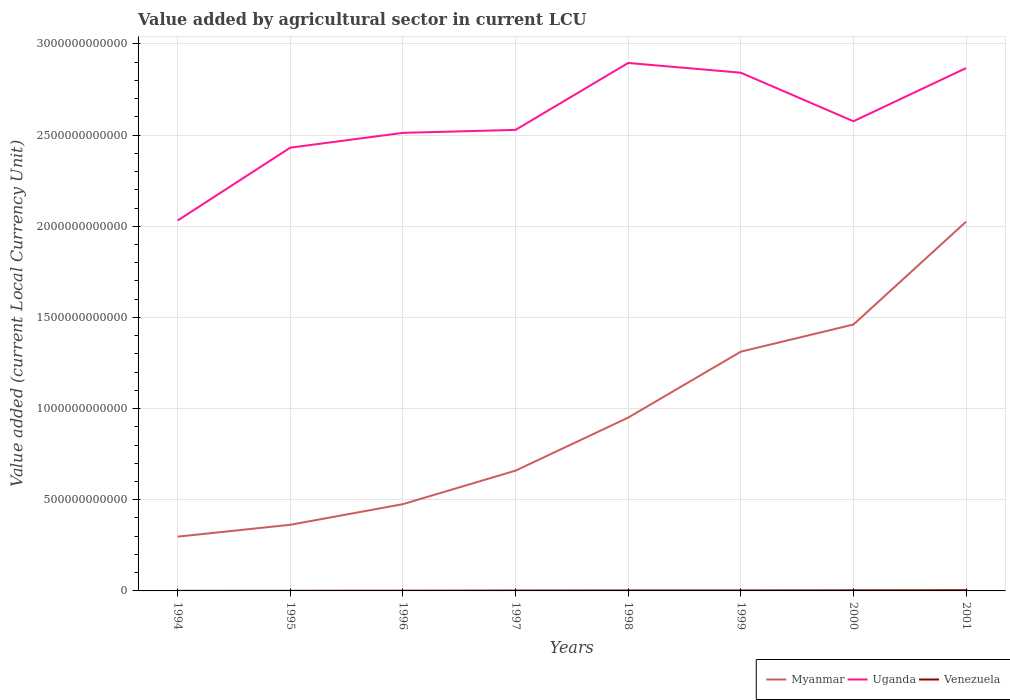Across all years, what is the maximum value added by agricultural sector in Myanmar?
Provide a short and direct response. 2.98e+11. In which year was the value added by agricultural sector in Venezuela maximum?
Provide a short and direct response. 1994. What is the total value added by agricultural sector in Uganda in the graph?
Provide a succinct answer. -6.37e+1. What is the difference between the highest and the second highest value added by agricultural sector in Uganda?
Ensure brevity in your answer.  8.64e+11. What is the difference between the highest and the lowest value added by agricultural sector in Venezuela?
Provide a succinct answer. 4. Is the value added by agricultural sector in Myanmar strictly greater than the value added by agricultural sector in Venezuela over the years?
Offer a very short reply. No. How many years are there in the graph?
Provide a short and direct response. 8. What is the difference between two consecutive major ticks on the Y-axis?
Give a very brief answer. 5.00e+11. Are the values on the major ticks of Y-axis written in scientific E-notation?
Make the answer very short. No. Where does the legend appear in the graph?
Keep it short and to the point. Bottom right. How many legend labels are there?
Give a very brief answer. 3. What is the title of the graph?
Give a very brief answer. Value added by agricultural sector in current LCU. Does "World" appear as one of the legend labels in the graph?
Ensure brevity in your answer.  No. What is the label or title of the X-axis?
Provide a short and direct response. Years. What is the label or title of the Y-axis?
Ensure brevity in your answer.  Value added (current Local Currency Unit). What is the Value added (current Local Currency Unit) in Myanmar in 1994?
Offer a very short reply. 2.98e+11. What is the Value added (current Local Currency Unit) of Uganda in 1994?
Make the answer very short. 2.03e+12. What is the Value added (current Local Currency Unit) of Venezuela in 1994?
Make the answer very short. 4.23e+08. What is the Value added (current Local Currency Unit) of Myanmar in 1995?
Your answer should be very brief. 3.63e+11. What is the Value added (current Local Currency Unit) in Uganda in 1995?
Your answer should be very brief. 2.43e+12. What is the Value added (current Local Currency Unit) of Venezuela in 1995?
Give a very brief answer. 6.90e+08. What is the Value added (current Local Currency Unit) in Myanmar in 1996?
Give a very brief answer. 4.76e+11. What is the Value added (current Local Currency Unit) in Uganda in 1996?
Give a very brief answer. 2.51e+12. What is the Value added (current Local Currency Unit) in Venezuela in 1996?
Offer a terse response. 1.20e+09. What is the Value added (current Local Currency Unit) of Myanmar in 1997?
Provide a succinct answer. 6.60e+11. What is the Value added (current Local Currency Unit) in Uganda in 1997?
Your answer should be very brief. 2.53e+12. What is the Value added (current Local Currency Unit) of Venezuela in 1997?
Offer a very short reply. 1.89e+09. What is the Value added (current Local Currency Unit) in Myanmar in 1998?
Your answer should be very brief. 9.51e+11. What is the Value added (current Local Currency Unit) of Uganda in 1998?
Your response must be concise. 2.90e+12. What is the Value added (current Local Currency Unit) in Venezuela in 1998?
Your answer should be compact. 2.48e+09. What is the Value added (current Local Currency Unit) of Myanmar in 1999?
Provide a short and direct response. 1.31e+12. What is the Value added (current Local Currency Unit) in Uganda in 1999?
Offer a terse response. 2.84e+12. What is the Value added (current Local Currency Unit) in Venezuela in 1999?
Offer a very short reply. 2.58e+09. What is the Value added (current Local Currency Unit) in Myanmar in 2000?
Provide a succinct answer. 1.46e+12. What is the Value added (current Local Currency Unit) of Uganda in 2000?
Provide a succinct answer. 2.58e+12. What is the Value added (current Local Currency Unit) in Venezuela in 2000?
Your answer should be compact. 3.13e+09. What is the Value added (current Local Currency Unit) of Myanmar in 2001?
Make the answer very short. 2.03e+12. What is the Value added (current Local Currency Unit) in Uganda in 2001?
Provide a succinct answer. 2.87e+12. What is the Value added (current Local Currency Unit) in Venezuela in 2001?
Provide a succinct answer. 3.76e+09. Across all years, what is the maximum Value added (current Local Currency Unit) of Myanmar?
Your answer should be very brief. 2.03e+12. Across all years, what is the maximum Value added (current Local Currency Unit) of Uganda?
Offer a terse response. 2.90e+12. Across all years, what is the maximum Value added (current Local Currency Unit) in Venezuela?
Offer a terse response. 3.76e+09. Across all years, what is the minimum Value added (current Local Currency Unit) in Myanmar?
Provide a succinct answer. 2.98e+11. Across all years, what is the minimum Value added (current Local Currency Unit) in Uganda?
Provide a short and direct response. 2.03e+12. Across all years, what is the minimum Value added (current Local Currency Unit) of Venezuela?
Give a very brief answer. 4.23e+08. What is the total Value added (current Local Currency Unit) of Myanmar in the graph?
Provide a short and direct response. 7.55e+12. What is the total Value added (current Local Currency Unit) in Uganda in the graph?
Give a very brief answer. 2.07e+13. What is the total Value added (current Local Currency Unit) of Venezuela in the graph?
Offer a very short reply. 1.62e+1. What is the difference between the Value added (current Local Currency Unit) in Myanmar in 1994 and that in 1995?
Your answer should be compact. -6.51e+1. What is the difference between the Value added (current Local Currency Unit) of Uganda in 1994 and that in 1995?
Offer a terse response. -4.00e+11. What is the difference between the Value added (current Local Currency Unit) in Venezuela in 1994 and that in 1995?
Your answer should be very brief. -2.66e+08. What is the difference between the Value added (current Local Currency Unit) of Myanmar in 1994 and that in 1996?
Your answer should be very brief. -1.78e+11. What is the difference between the Value added (current Local Currency Unit) of Uganda in 1994 and that in 1996?
Ensure brevity in your answer.  -4.81e+11. What is the difference between the Value added (current Local Currency Unit) of Venezuela in 1994 and that in 1996?
Provide a succinct answer. -7.81e+08. What is the difference between the Value added (current Local Currency Unit) of Myanmar in 1994 and that in 1997?
Your answer should be very brief. -3.62e+11. What is the difference between the Value added (current Local Currency Unit) of Uganda in 1994 and that in 1997?
Ensure brevity in your answer.  -4.97e+11. What is the difference between the Value added (current Local Currency Unit) in Venezuela in 1994 and that in 1997?
Ensure brevity in your answer.  -1.46e+09. What is the difference between the Value added (current Local Currency Unit) of Myanmar in 1994 and that in 1998?
Give a very brief answer. -6.53e+11. What is the difference between the Value added (current Local Currency Unit) in Uganda in 1994 and that in 1998?
Offer a very short reply. -8.64e+11. What is the difference between the Value added (current Local Currency Unit) in Venezuela in 1994 and that in 1998?
Make the answer very short. -2.05e+09. What is the difference between the Value added (current Local Currency Unit) of Myanmar in 1994 and that in 1999?
Your answer should be very brief. -1.01e+12. What is the difference between the Value added (current Local Currency Unit) in Uganda in 1994 and that in 1999?
Keep it short and to the point. -8.11e+11. What is the difference between the Value added (current Local Currency Unit) of Venezuela in 1994 and that in 1999?
Ensure brevity in your answer.  -2.16e+09. What is the difference between the Value added (current Local Currency Unit) in Myanmar in 1994 and that in 2000?
Your answer should be compact. -1.16e+12. What is the difference between the Value added (current Local Currency Unit) in Uganda in 1994 and that in 2000?
Ensure brevity in your answer.  -5.44e+11. What is the difference between the Value added (current Local Currency Unit) of Venezuela in 1994 and that in 2000?
Keep it short and to the point. -2.71e+09. What is the difference between the Value added (current Local Currency Unit) in Myanmar in 1994 and that in 2001?
Provide a succinct answer. -1.73e+12. What is the difference between the Value added (current Local Currency Unit) of Uganda in 1994 and that in 2001?
Your answer should be compact. -8.36e+11. What is the difference between the Value added (current Local Currency Unit) of Venezuela in 1994 and that in 2001?
Provide a succinct answer. -3.34e+09. What is the difference between the Value added (current Local Currency Unit) of Myanmar in 1995 and that in 1996?
Provide a short and direct response. -1.13e+11. What is the difference between the Value added (current Local Currency Unit) in Uganda in 1995 and that in 1996?
Your answer should be very brief. -8.11e+1. What is the difference between the Value added (current Local Currency Unit) of Venezuela in 1995 and that in 1996?
Ensure brevity in your answer.  -5.14e+08. What is the difference between the Value added (current Local Currency Unit) in Myanmar in 1995 and that in 1997?
Keep it short and to the point. -2.97e+11. What is the difference between the Value added (current Local Currency Unit) of Uganda in 1995 and that in 1997?
Offer a very short reply. -9.75e+1. What is the difference between the Value added (current Local Currency Unit) in Venezuela in 1995 and that in 1997?
Keep it short and to the point. -1.20e+09. What is the difference between the Value added (current Local Currency Unit) of Myanmar in 1995 and that in 1998?
Keep it short and to the point. -5.88e+11. What is the difference between the Value added (current Local Currency Unit) in Uganda in 1995 and that in 1998?
Provide a succinct answer. -4.64e+11. What is the difference between the Value added (current Local Currency Unit) in Venezuela in 1995 and that in 1998?
Offer a very short reply. -1.79e+09. What is the difference between the Value added (current Local Currency Unit) in Myanmar in 1995 and that in 1999?
Make the answer very short. -9.50e+11. What is the difference between the Value added (current Local Currency Unit) in Uganda in 1995 and that in 1999?
Offer a very short reply. -4.11e+11. What is the difference between the Value added (current Local Currency Unit) in Venezuela in 1995 and that in 1999?
Provide a short and direct response. -1.89e+09. What is the difference between the Value added (current Local Currency Unit) in Myanmar in 1995 and that in 2000?
Ensure brevity in your answer.  -1.10e+12. What is the difference between the Value added (current Local Currency Unit) of Uganda in 1995 and that in 2000?
Make the answer very short. -1.45e+11. What is the difference between the Value added (current Local Currency Unit) in Venezuela in 1995 and that in 2000?
Give a very brief answer. -2.44e+09. What is the difference between the Value added (current Local Currency Unit) in Myanmar in 1995 and that in 2001?
Keep it short and to the point. -1.66e+12. What is the difference between the Value added (current Local Currency Unit) of Uganda in 1995 and that in 2001?
Your response must be concise. -4.36e+11. What is the difference between the Value added (current Local Currency Unit) of Venezuela in 1995 and that in 2001?
Keep it short and to the point. -3.07e+09. What is the difference between the Value added (current Local Currency Unit) in Myanmar in 1996 and that in 1997?
Provide a short and direct response. -1.84e+11. What is the difference between the Value added (current Local Currency Unit) of Uganda in 1996 and that in 1997?
Offer a very short reply. -1.63e+1. What is the difference between the Value added (current Local Currency Unit) of Venezuela in 1996 and that in 1997?
Give a very brief answer. -6.82e+08. What is the difference between the Value added (current Local Currency Unit) of Myanmar in 1996 and that in 1998?
Ensure brevity in your answer.  -4.75e+11. What is the difference between the Value added (current Local Currency Unit) of Uganda in 1996 and that in 1998?
Make the answer very short. -3.83e+11. What is the difference between the Value added (current Local Currency Unit) of Venezuela in 1996 and that in 1998?
Provide a short and direct response. -1.27e+09. What is the difference between the Value added (current Local Currency Unit) in Myanmar in 1996 and that in 1999?
Give a very brief answer. -8.36e+11. What is the difference between the Value added (current Local Currency Unit) of Uganda in 1996 and that in 1999?
Your answer should be compact. -3.30e+11. What is the difference between the Value added (current Local Currency Unit) of Venezuela in 1996 and that in 1999?
Keep it short and to the point. -1.38e+09. What is the difference between the Value added (current Local Currency Unit) of Myanmar in 1996 and that in 2000?
Provide a short and direct response. -9.85e+11. What is the difference between the Value added (current Local Currency Unit) in Uganda in 1996 and that in 2000?
Offer a very short reply. -6.37e+1. What is the difference between the Value added (current Local Currency Unit) of Venezuela in 1996 and that in 2000?
Provide a short and direct response. -1.93e+09. What is the difference between the Value added (current Local Currency Unit) in Myanmar in 1996 and that in 2001?
Give a very brief answer. -1.55e+12. What is the difference between the Value added (current Local Currency Unit) of Uganda in 1996 and that in 2001?
Offer a terse response. -3.55e+11. What is the difference between the Value added (current Local Currency Unit) in Venezuela in 1996 and that in 2001?
Ensure brevity in your answer.  -2.56e+09. What is the difference between the Value added (current Local Currency Unit) of Myanmar in 1997 and that in 1998?
Provide a succinct answer. -2.91e+11. What is the difference between the Value added (current Local Currency Unit) in Uganda in 1997 and that in 1998?
Provide a succinct answer. -3.67e+11. What is the difference between the Value added (current Local Currency Unit) of Venezuela in 1997 and that in 1998?
Offer a very short reply. -5.90e+08. What is the difference between the Value added (current Local Currency Unit) in Myanmar in 1997 and that in 1999?
Give a very brief answer. -6.53e+11. What is the difference between the Value added (current Local Currency Unit) in Uganda in 1997 and that in 1999?
Provide a succinct answer. -3.14e+11. What is the difference between the Value added (current Local Currency Unit) in Venezuela in 1997 and that in 1999?
Offer a very short reply. -6.97e+08. What is the difference between the Value added (current Local Currency Unit) in Myanmar in 1997 and that in 2000?
Your answer should be very brief. -8.01e+11. What is the difference between the Value added (current Local Currency Unit) of Uganda in 1997 and that in 2000?
Offer a very short reply. -4.74e+1. What is the difference between the Value added (current Local Currency Unit) of Venezuela in 1997 and that in 2000?
Give a very brief answer. -1.25e+09. What is the difference between the Value added (current Local Currency Unit) in Myanmar in 1997 and that in 2001?
Your answer should be very brief. -1.37e+12. What is the difference between the Value added (current Local Currency Unit) of Uganda in 1997 and that in 2001?
Offer a very short reply. -3.39e+11. What is the difference between the Value added (current Local Currency Unit) of Venezuela in 1997 and that in 2001?
Offer a very short reply. -1.88e+09. What is the difference between the Value added (current Local Currency Unit) in Myanmar in 1998 and that in 1999?
Ensure brevity in your answer.  -3.62e+11. What is the difference between the Value added (current Local Currency Unit) in Uganda in 1998 and that in 1999?
Your answer should be compact. 5.34e+1. What is the difference between the Value added (current Local Currency Unit) of Venezuela in 1998 and that in 1999?
Offer a very short reply. -1.06e+08. What is the difference between the Value added (current Local Currency Unit) of Myanmar in 1998 and that in 2000?
Provide a succinct answer. -5.11e+11. What is the difference between the Value added (current Local Currency Unit) of Uganda in 1998 and that in 2000?
Offer a terse response. 3.20e+11. What is the difference between the Value added (current Local Currency Unit) of Venezuela in 1998 and that in 2000?
Ensure brevity in your answer.  -6.57e+08. What is the difference between the Value added (current Local Currency Unit) of Myanmar in 1998 and that in 2001?
Provide a succinct answer. -1.07e+12. What is the difference between the Value added (current Local Currency Unit) of Uganda in 1998 and that in 2001?
Your answer should be compact. 2.81e+1. What is the difference between the Value added (current Local Currency Unit) of Venezuela in 1998 and that in 2001?
Keep it short and to the point. -1.29e+09. What is the difference between the Value added (current Local Currency Unit) of Myanmar in 1999 and that in 2000?
Offer a terse response. -1.49e+11. What is the difference between the Value added (current Local Currency Unit) of Uganda in 1999 and that in 2000?
Your answer should be very brief. 2.66e+11. What is the difference between the Value added (current Local Currency Unit) of Venezuela in 1999 and that in 2000?
Make the answer very short. -5.51e+08. What is the difference between the Value added (current Local Currency Unit) of Myanmar in 1999 and that in 2001?
Keep it short and to the point. -7.13e+11. What is the difference between the Value added (current Local Currency Unit) in Uganda in 1999 and that in 2001?
Your response must be concise. -2.53e+1. What is the difference between the Value added (current Local Currency Unit) of Venezuela in 1999 and that in 2001?
Provide a short and direct response. -1.18e+09. What is the difference between the Value added (current Local Currency Unit) of Myanmar in 2000 and that in 2001?
Provide a short and direct response. -5.64e+11. What is the difference between the Value added (current Local Currency Unit) in Uganda in 2000 and that in 2001?
Ensure brevity in your answer.  -2.92e+11. What is the difference between the Value added (current Local Currency Unit) in Venezuela in 2000 and that in 2001?
Your answer should be compact. -6.31e+08. What is the difference between the Value added (current Local Currency Unit) in Myanmar in 1994 and the Value added (current Local Currency Unit) in Uganda in 1995?
Make the answer very short. -2.13e+12. What is the difference between the Value added (current Local Currency Unit) of Myanmar in 1994 and the Value added (current Local Currency Unit) of Venezuela in 1995?
Give a very brief answer. 2.97e+11. What is the difference between the Value added (current Local Currency Unit) of Uganda in 1994 and the Value added (current Local Currency Unit) of Venezuela in 1995?
Offer a terse response. 2.03e+12. What is the difference between the Value added (current Local Currency Unit) in Myanmar in 1994 and the Value added (current Local Currency Unit) in Uganda in 1996?
Make the answer very short. -2.21e+12. What is the difference between the Value added (current Local Currency Unit) in Myanmar in 1994 and the Value added (current Local Currency Unit) in Venezuela in 1996?
Give a very brief answer. 2.96e+11. What is the difference between the Value added (current Local Currency Unit) in Uganda in 1994 and the Value added (current Local Currency Unit) in Venezuela in 1996?
Make the answer very short. 2.03e+12. What is the difference between the Value added (current Local Currency Unit) in Myanmar in 1994 and the Value added (current Local Currency Unit) in Uganda in 1997?
Provide a succinct answer. -2.23e+12. What is the difference between the Value added (current Local Currency Unit) of Myanmar in 1994 and the Value added (current Local Currency Unit) of Venezuela in 1997?
Your answer should be compact. 2.96e+11. What is the difference between the Value added (current Local Currency Unit) of Uganda in 1994 and the Value added (current Local Currency Unit) of Venezuela in 1997?
Your answer should be very brief. 2.03e+12. What is the difference between the Value added (current Local Currency Unit) in Myanmar in 1994 and the Value added (current Local Currency Unit) in Uganda in 1998?
Give a very brief answer. -2.60e+12. What is the difference between the Value added (current Local Currency Unit) of Myanmar in 1994 and the Value added (current Local Currency Unit) of Venezuela in 1998?
Give a very brief answer. 2.95e+11. What is the difference between the Value added (current Local Currency Unit) of Uganda in 1994 and the Value added (current Local Currency Unit) of Venezuela in 1998?
Ensure brevity in your answer.  2.03e+12. What is the difference between the Value added (current Local Currency Unit) of Myanmar in 1994 and the Value added (current Local Currency Unit) of Uganda in 1999?
Your answer should be very brief. -2.54e+12. What is the difference between the Value added (current Local Currency Unit) in Myanmar in 1994 and the Value added (current Local Currency Unit) in Venezuela in 1999?
Offer a very short reply. 2.95e+11. What is the difference between the Value added (current Local Currency Unit) in Uganda in 1994 and the Value added (current Local Currency Unit) in Venezuela in 1999?
Offer a terse response. 2.03e+12. What is the difference between the Value added (current Local Currency Unit) in Myanmar in 1994 and the Value added (current Local Currency Unit) in Uganda in 2000?
Provide a succinct answer. -2.28e+12. What is the difference between the Value added (current Local Currency Unit) in Myanmar in 1994 and the Value added (current Local Currency Unit) in Venezuela in 2000?
Your answer should be compact. 2.95e+11. What is the difference between the Value added (current Local Currency Unit) of Uganda in 1994 and the Value added (current Local Currency Unit) of Venezuela in 2000?
Your answer should be very brief. 2.03e+12. What is the difference between the Value added (current Local Currency Unit) in Myanmar in 1994 and the Value added (current Local Currency Unit) in Uganda in 2001?
Ensure brevity in your answer.  -2.57e+12. What is the difference between the Value added (current Local Currency Unit) of Myanmar in 1994 and the Value added (current Local Currency Unit) of Venezuela in 2001?
Ensure brevity in your answer.  2.94e+11. What is the difference between the Value added (current Local Currency Unit) of Uganda in 1994 and the Value added (current Local Currency Unit) of Venezuela in 2001?
Make the answer very short. 2.03e+12. What is the difference between the Value added (current Local Currency Unit) in Myanmar in 1995 and the Value added (current Local Currency Unit) in Uganda in 1996?
Offer a very short reply. -2.15e+12. What is the difference between the Value added (current Local Currency Unit) of Myanmar in 1995 and the Value added (current Local Currency Unit) of Venezuela in 1996?
Your answer should be compact. 3.62e+11. What is the difference between the Value added (current Local Currency Unit) of Uganda in 1995 and the Value added (current Local Currency Unit) of Venezuela in 1996?
Provide a succinct answer. 2.43e+12. What is the difference between the Value added (current Local Currency Unit) in Myanmar in 1995 and the Value added (current Local Currency Unit) in Uganda in 1997?
Provide a succinct answer. -2.17e+12. What is the difference between the Value added (current Local Currency Unit) in Myanmar in 1995 and the Value added (current Local Currency Unit) in Venezuela in 1997?
Make the answer very short. 3.61e+11. What is the difference between the Value added (current Local Currency Unit) of Uganda in 1995 and the Value added (current Local Currency Unit) of Venezuela in 1997?
Your response must be concise. 2.43e+12. What is the difference between the Value added (current Local Currency Unit) in Myanmar in 1995 and the Value added (current Local Currency Unit) in Uganda in 1998?
Offer a terse response. -2.53e+12. What is the difference between the Value added (current Local Currency Unit) in Myanmar in 1995 and the Value added (current Local Currency Unit) in Venezuela in 1998?
Keep it short and to the point. 3.60e+11. What is the difference between the Value added (current Local Currency Unit) of Uganda in 1995 and the Value added (current Local Currency Unit) of Venezuela in 1998?
Ensure brevity in your answer.  2.43e+12. What is the difference between the Value added (current Local Currency Unit) in Myanmar in 1995 and the Value added (current Local Currency Unit) in Uganda in 1999?
Provide a short and direct response. -2.48e+12. What is the difference between the Value added (current Local Currency Unit) of Myanmar in 1995 and the Value added (current Local Currency Unit) of Venezuela in 1999?
Make the answer very short. 3.60e+11. What is the difference between the Value added (current Local Currency Unit) of Uganda in 1995 and the Value added (current Local Currency Unit) of Venezuela in 1999?
Make the answer very short. 2.43e+12. What is the difference between the Value added (current Local Currency Unit) in Myanmar in 1995 and the Value added (current Local Currency Unit) in Uganda in 2000?
Give a very brief answer. -2.21e+12. What is the difference between the Value added (current Local Currency Unit) in Myanmar in 1995 and the Value added (current Local Currency Unit) in Venezuela in 2000?
Your answer should be compact. 3.60e+11. What is the difference between the Value added (current Local Currency Unit) in Uganda in 1995 and the Value added (current Local Currency Unit) in Venezuela in 2000?
Your response must be concise. 2.43e+12. What is the difference between the Value added (current Local Currency Unit) of Myanmar in 1995 and the Value added (current Local Currency Unit) of Uganda in 2001?
Give a very brief answer. -2.50e+12. What is the difference between the Value added (current Local Currency Unit) of Myanmar in 1995 and the Value added (current Local Currency Unit) of Venezuela in 2001?
Ensure brevity in your answer.  3.59e+11. What is the difference between the Value added (current Local Currency Unit) of Uganda in 1995 and the Value added (current Local Currency Unit) of Venezuela in 2001?
Keep it short and to the point. 2.43e+12. What is the difference between the Value added (current Local Currency Unit) of Myanmar in 1996 and the Value added (current Local Currency Unit) of Uganda in 1997?
Your answer should be very brief. -2.05e+12. What is the difference between the Value added (current Local Currency Unit) of Myanmar in 1996 and the Value added (current Local Currency Unit) of Venezuela in 1997?
Offer a very short reply. 4.74e+11. What is the difference between the Value added (current Local Currency Unit) in Uganda in 1996 and the Value added (current Local Currency Unit) in Venezuela in 1997?
Offer a terse response. 2.51e+12. What is the difference between the Value added (current Local Currency Unit) in Myanmar in 1996 and the Value added (current Local Currency Unit) in Uganda in 1998?
Provide a short and direct response. -2.42e+12. What is the difference between the Value added (current Local Currency Unit) of Myanmar in 1996 and the Value added (current Local Currency Unit) of Venezuela in 1998?
Keep it short and to the point. 4.73e+11. What is the difference between the Value added (current Local Currency Unit) in Uganda in 1996 and the Value added (current Local Currency Unit) in Venezuela in 1998?
Make the answer very short. 2.51e+12. What is the difference between the Value added (current Local Currency Unit) in Myanmar in 1996 and the Value added (current Local Currency Unit) in Uganda in 1999?
Your answer should be very brief. -2.37e+12. What is the difference between the Value added (current Local Currency Unit) in Myanmar in 1996 and the Value added (current Local Currency Unit) in Venezuela in 1999?
Your response must be concise. 4.73e+11. What is the difference between the Value added (current Local Currency Unit) of Uganda in 1996 and the Value added (current Local Currency Unit) of Venezuela in 1999?
Keep it short and to the point. 2.51e+12. What is the difference between the Value added (current Local Currency Unit) of Myanmar in 1996 and the Value added (current Local Currency Unit) of Uganda in 2000?
Make the answer very short. -2.10e+12. What is the difference between the Value added (current Local Currency Unit) in Myanmar in 1996 and the Value added (current Local Currency Unit) in Venezuela in 2000?
Offer a terse response. 4.73e+11. What is the difference between the Value added (current Local Currency Unit) in Uganda in 1996 and the Value added (current Local Currency Unit) in Venezuela in 2000?
Your response must be concise. 2.51e+12. What is the difference between the Value added (current Local Currency Unit) of Myanmar in 1996 and the Value added (current Local Currency Unit) of Uganda in 2001?
Give a very brief answer. -2.39e+12. What is the difference between the Value added (current Local Currency Unit) in Myanmar in 1996 and the Value added (current Local Currency Unit) in Venezuela in 2001?
Provide a short and direct response. 4.72e+11. What is the difference between the Value added (current Local Currency Unit) in Uganda in 1996 and the Value added (current Local Currency Unit) in Venezuela in 2001?
Ensure brevity in your answer.  2.51e+12. What is the difference between the Value added (current Local Currency Unit) of Myanmar in 1997 and the Value added (current Local Currency Unit) of Uganda in 1998?
Your response must be concise. -2.24e+12. What is the difference between the Value added (current Local Currency Unit) of Myanmar in 1997 and the Value added (current Local Currency Unit) of Venezuela in 1998?
Ensure brevity in your answer.  6.57e+11. What is the difference between the Value added (current Local Currency Unit) of Uganda in 1997 and the Value added (current Local Currency Unit) of Venezuela in 1998?
Provide a short and direct response. 2.53e+12. What is the difference between the Value added (current Local Currency Unit) in Myanmar in 1997 and the Value added (current Local Currency Unit) in Uganda in 1999?
Your response must be concise. -2.18e+12. What is the difference between the Value added (current Local Currency Unit) in Myanmar in 1997 and the Value added (current Local Currency Unit) in Venezuela in 1999?
Provide a short and direct response. 6.57e+11. What is the difference between the Value added (current Local Currency Unit) in Uganda in 1997 and the Value added (current Local Currency Unit) in Venezuela in 1999?
Keep it short and to the point. 2.53e+12. What is the difference between the Value added (current Local Currency Unit) in Myanmar in 1997 and the Value added (current Local Currency Unit) in Uganda in 2000?
Keep it short and to the point. -1.92e+12. What is the difference between the Value added (current Local Currency Unit) in Myanmar in 1997 and the Value added (current Local Currency Unit) in Venezuela in 2000?
Offer a very short reply. 6.57e+11. What is the difference between the Value added (current Local Currency Unit) in Uganda in 1997 and the Value added (current Local Currency Unit) in Venezuela in 2000?
Offer a terse response. 2.53e+12. What is the difference between the Value added (current Local Currency Unit) in Myanmar in 1997 and the Value added (current Local Currency Unit) in Uganda in 2001?
Your response must be concise. -2.21e+12. What is the difference between the Value added (current Local Currency Unit) of Myanmar in 1997 and the Value added (current Local Currency Unit) of Venezuela in 2001?
Ensure brevity in your answer.  6.56e+11. What is the difference between the Value added (current Local Currency Unit) of Uganda in 1997 and the Value added (current Local Currency Unit) of Venezuela in 2001?
Provide a succinct answer. 2.52e+12. What is the difference between the Value added (current Local Currency Unit) in Myanmar in 1998 and the Value added (current Local Currency Unit) in Uganda in 1999?
Your answer should be compact. -1.89e+12. What is the difference between the Value added (current Local Currency Unit) in Myanmar in 1998 and the Value added (current Local Currency Unit) in Venezuela in 1999?
Keep it short and to the point. 9.48e+11. What is the difference between the Value added (current Local Currency Unit) of Uganda in 1998 and the Value added (current Local Currency Unit) of Venezuela in 1999?
Offer a very short reply. 2.89e+12. What is the difference between the Value added (current Local Currency Unit) of Myanmar in 1998 and the Value added (current Local Currency Unit) of Uganda in 2000?
Keep it short and to the point. -1.63e+12. What is the difference between the Value added (current Local Currency Unit) in Myanmar in 1998 and the Value added (current Local Currency Unit) in Venezuela in 2000?
Provide a short and direct response. 9.47e+11. What is the difference between the Value added (current Local Currency Unit) in Uganda in 1998 and the Value added (current Local Currency Unit) in Venezuela in 2000?
Keep it short and to the point. 2.89e+12. What is the difference between the Value added (current Local Currency Unit) of Myanmar in 1998 and the Value added (current Local Currency Unit) of Uganda in 2001?
Provide a succinct answer. -1.92e+12. What is the difference between the Value added (current Local Currency Unit) of Myanmar in 1998 and the Value added (current Local Currency Unit) of Venezuela in 2001?
Provide a short and direct response. 9.47e+11. What is the difference between the Value added (current Local Currency Unit) of Uganda in 1998 and the Value added (current Local Currency Unit) of Venezuela in 2001?
Your answer should be very brief. 2.89e+12. What is the difference between the Value added (current Local Currency Unit) in Myanmar in 1999 and the Value added (current Local Currency Unit) in Uganda in 2000?
Your answer should be very brief. -1.26e+12. What is the difference between the Value added (current Local Currency Unit) in Myanmar in 1999 and the Value added (current Local Currency Unit) in Venezuela in 2000?
Give a very brief answer. 1.31e+12. What is the difference between the Value added (current Local Currency Unit) in Uganda in 1999 and the Value added (current Local Currency Unit) in Venezuela in 2000?
Provide a succinct answer. 2.84e+12. What is the difference between the Value added (current Local Currency Unit) in Myanmar in 1999 and the Value added (current Local Currency Unit) in Uganda in 2001?
Give a very brief answer. -1.56e+12. What is the difference between the Value added (current Local Currency Unit) of Myanmar in 1999 and the Value added (current Local Currency Unit) of Venezuela in 2001?
Your response must be concise. 1.31e+12. What is the difference between the Value added (current Local Currency Unit) in Uganda in 1999 and the Value added (current Local Currency Unit) in Venezuela in 2001?
Offer a very short reply. 2.84e+12. What is the difference between the Value added (current Local Currency Unit) of Myanmar in 2000 and the Value added (current Local Currency Unit) of Uganda in 2001?
Make the answer very short. -1.41e+12. What is the difference between the Value added (current Local Currency Unit) in Myanmar in 2000 and the Value added (current Local Currency Unit) in Venezuela in 2001?
Provide a short and direct response. 1.46e+12. What is the difference between the Value added (current Local Currency Unit) in Uganda in 2000 and the Value added (current Local Currency Unit) in Venezuela in 2001?
Keep it short and to the point. 2.57e+12. What is the average Value added (current Local Currency Unit) in Myanmar per year?
Keep it short and to the point. 9.43e+11. What is the average Value added (current Local Currency Unit) in Uganda per year?
Ensure brevity in your answer.  2.59e+12. What is the average Value added (current Local Currency Unit) in Venezuela per year?
Provide a short and direct response. 2.02e+09. In the year 1994, what is the difference between the Value added (current Local Currency Unit) in Myanmar and Value added (current Local Currency Unit) in Uganda?
Offer a very short reply. -1.73e+12. In the year 1994, what is the difference between the Value added (current Local Currency Unit) of Myanmar and Value added (current Local Currency Unit) of Venezuela?
Your answer should be compact. 2.97e+11. In the year 1994, what is the difference between the Value added (current Local Currency Unit) of Uganda and Value added (current Local Currency Unit) of Venezuela?
Offer a terse response. 2.03e+12. In the year 1995, what is the difference between the Value added (current Local Currency Unit) of Myanmar and Value added (current Local Currency Unit) of Uganda?
Offer a very short reply. -2.07e+12. In the year 1995, what is the difference between the Value added (current Local Currency Unit) of Myanmar and Value added (current Local Currency Unit) of Venezuela?
Your answer should be very brief. 3.62e+11. In the year 1995, what is the difference between the Value added (current Local Currency Unit) in Uganda and Value added (current Local Currency Unit) in Venezuela?
Ensure brevity in your answer.  2.43e+12. In the year 1996, what is the difference between the Value added (current Local Currency Unit) of Myanmar and Value added (current Local Currency Unit) of Uganda?
Give a very brief answer. -2.04e+12. In the year 1996, what is the difference between the Value added (current Local Currency Unit) of Myanmar and Value added (current Local Currency Unit) of Venezuela?
Make the answer very short. 4.75e+11. In the year 1996, what is the difference between the Value added (current Local Currency Unit) of Uganda and Value added (current Local Currency Unit) of Venezuela?
Ensure brevity in your answer.  2.51e+12. In the year 1997, what is the difference between the Value added (current Local Currency Unit) in Myanmar and Value added (current Local Currency Unit) in Uganda?
Give a very brief answer. -1.87e+12. In the year 1997, what is the difference between the Value added (current Local Currency Unit) in Myanmar and Value added (current Local Currency Unit) in Venezuela?
Provide a succinct answer. 6.58e+11. In the year 1997, what is the difference between the Value added (current Local Currency Unit) in Uganda and Value added (current Local Currency Unit) in Venezuela?
Provide a succinct answer. 2.53e+12. In the year 1998, what is the difference between the Value added (current Local Currency Unit) of Myanmar and Value added (current Local Currency Unit) of Uganda?
Provide a short and direct response. -1.95e+12. In the year 1998, what is the difference between the Value added (current Local Currency Unit) in Myanmar and Value added (current Local Currency Unit) in Venezuela?
Provide a succinct answer. 9.48e+11. In the year 1998, what is the difference between the Value added (current Local Currency Unit) of Uganda and Value added (current Local Currency Unit) of Venezuela?
Provide a short and direct response. 2.89e+12. In the year 1999, what is the difference between the Value added (current Local Currency Unit) in Myanmar and Value added (current Local Currency Unit) in Uganda?
Give a very brief answer. -1.53e+12. In the year 1999, what is the difference between the Value added (current Local Currency Unit) in Myanmar and Value added (current Local Currency Unit) in Venezuela?
Ensure brevity in your answer.  1.31e+12. In the year 1999, what is the difference between the Value added (current Local Currency Unit) in Uganda and Value added (current Local Currency Unit) in Venezuela?
Offer a very short reply. 2.84e+12. In the year 2000, what is the difference between the Value added (current Local Currency Unit) of Myanmar and Value added (current Local Currency Unit) of Uganda?
Your response must be concise. -1.11e+12. In the year 2000, what is the difference between the Value added (current Local Currency Unit) in Myanmar and Value added (current Local Currency Unit) in Venezuela?
Ensure brevity in your answer.  1.46e+12. In the year 2000, what is the difference between the Value added (current Local Currency Unit) in Uganda and Value added (current Local Currency Unit) in Venezuela?
Ensure brevity in your answer.  2.57e+12. In the year 2001, what is the difference between the Value added (current Local Currency Unit) in Myanmar and Value added (current Local Currency Unit) in Uganda?
Give a very brief answer. -8.42e+11. In the year 2001, what is the difference between the Value added (current Local Currency Unit) in Myanmar and Value added (current Local Currency Unit) in Venezuela?
Ensure brevity in your answer.  2.02e+12. In the year 2001, what is the difference between the Value added (current Local Currency Unit) in Uganda and Value added (current Local Currency Unit) in Venezuela?
Provide a succinct answer. 2.86e+12. What is the ratio of the Value added (current Local Currency Unit) in Myanmar in 1994 to that in 1995?
Your response must be concise. 0.82. What is the ratio of the Value added (current Local Currency Unit) of Uganda in 1994 to that in 1995?
Your answer should be compact. 0.84. What is the ratio of the Value added (current Local Currency Unit) in Venezuela in 1994 to that in 1995?
Your answer should be compact. 0.61. What is the ratio of the Value added (current Local Currency Unit) of Myanmar in 1994 to that in 1996?
Your response must be concise. 0.63. What is the ratio of the Value added (current Local Currency Unit) in Uganda in 1994 to that in 1996?
Provide a succinct answer. 0.81. What is the ratio of the Value added (current Local Currency Unit) in Venezuela in 1994 to that in 1996?
Offer a very short reply. 0.35. What is the ratio of the Value added (current Local Currency Unit) in Myanmar in 1994 to that in 1997?
Ensure brevity in your answer.  0.45. What is the ratio of the Value added (current Local Currency Unit) in Uganda in 1994 to that in 1997?
Offer a very short reply. 0.8. What is the ratio of the Value added (current Local Currency Unit) of Venezuela in 1994 to that in 1997?
Your answer should be very brief. 0.22. What is the ratio of the Value added (current Local Currency Unit) of Myanmar in 1994 to that in 1998?
Your answer should be very brief. 0.31. What is the ratio of the Value added (current Local Currency Unit) in Uganda in 1994 to that in 1998?
Ensure brevity in your answer.  0.7. What is the ratio of the Value added (current Local Currency Unit) in Venezuela in 1994 to that in 1998?
Give a very brief answer. 0.17. What is the ratio of the Value added (current Local Currency Unit) of Myanmar in 1994 to that in 1999?
Your answer should be compact. 0.23. What is the ratio of the Value added (current Local Currency Unit) in Uganda in 1994 to that in 1999?
Keep it short and to the point. 0.71. What is the ratio of the Value added (current Local Currency Unit) in Venezuela in 1994 to that in 1999?
Give a very brief answer. 0.16. What is the ratio of the Value added (current Local Currency Unit) in Myanmar in 1994 to that in 2000?
Give a very brief answer. 0.2. What is the ratio of the Value added (current Local Currency Unit) in Uganda in 1994 to that in 2000?
Your answer should be very brief. 0.79. What is the ratio of the Value added (current Local Currency Unit) of Venezuela in 1994 to that in 2000?
Offer a terse response. 0.14. What is the ratio of the Value added (current Local Currency Unit) of Myanmar in 1994 to that in 2001?
Give a very brief answer. 0.15. What is the ratio of the Value added (current Local Currency Unit) in Uganda in 1994 to that in 2001?
Provide a short and direct response. 0.71. What is the ratio of the Value added (current Local Currency Unit) of Venezuela in 1994 to that in 2001?
Offer a terse response. 0.11. What is the ratio of the Value added (current Local Currency Unit) of Myanmar in 1995 to that in 1996?
Give a very brief answer. 0.76. What is the ratio of the Value added (current Local Currency Unit) in Uganda in 1995 to that in 1996?
Provide a succinct answer. 0.97. What is the ratio of the Value added (current Local Currency Unit) in Venezuela in 1995 to that in 1996?
Your answer should be very brief. 0.57. What is the ratio of the Value added (current Local Currency Unit) in Myanmar in 1995 to that in 1997?
Offer a very short reply. 0.55. What is the ratio of the Value added (current Local Currency Unit) in Uganda in 1995 to that in 1997?
Give a very brief answer. 0.96. What is the ratio of the Value added (current Local Currency Unit) of Venezuela in 1995 to that in 1997?
Offer a very short reply. 0.37. What is the ratio of the Value added (current Local Currency Unit) of Myanmar in 1995 to that in 1998?
Offer a very short reply. 0.38. What is the ratio of the Value added (current Local Currency Unit) in Uganda in 1995 to that in 1998?
Keep it short and to the point. 0.84. What is the ratio of the Value added (current Local Currency Unit) of Venezuela in 1995 to that in 1998?
Provide a succinct answer. 0.28. What is the ratio of the Value added (current Local Currency Unit) of Myanmar in 1995 to that in 1999?
Your response must be concise. 0.28. What is the ratio of the Value added (current Local Currency Unit) in Uganda in 1995 to that in 1999?
Ensure brevity in your answer.  0.86. What is the ratio of the Value added (current Local Currency Unit) of Venezuela in 1995 to that in 1999?
Provide a succinct answer. 0.27. What is the ratio of the Value added (current Local Currency Unit) of Myanmar in 1995 to that in 2000?
Provide a succinct answer. 0.25. What is the ratio of the Value added (current Local Currency Unit) in Uganda in 1995 to that in 2000?
Provide a succinct answer. 0.94. What is the ratio of the Value added (current Local Currency Unit) of Venezuela in 1995 to that in 2000?
Make the answer very short. 0.22. What is the ratio of the Value added (current Local Currency Unit) of Myanmar in 1995 to that in 2001?
Your response must be concise. 0.18. What is the ratio of the Value added (current Local Currency Unit) of Uganda in 1995 to that in 2001?
Provide a short and direct response. 0.85. What is the ratio of the Value added (current Local Currency Unit) in Venezuela in 1995 to that in 2001?
Give a very brief answer. 0.18. What is the ratio of the Value added (current Local Currency Unit) in Myanmar in 1996 to that in 1997?
Offer a terse response. 0.72. What is the ratio of the Value added (current Local Currency Unit) in Uganda in 1996 to that in 1997?
Your response must be concise. 0.99. What is the ratio of the Value added (current Local Currency Unit) in Venezuela in 1996 to that in 1997?
Your answer should be compact. 0.64. What is the ratio of the Value added (current Local Currency Unit) in Myanmar in 1996 to that in 1998?
Offer a very short reply. 0.5. What is the ratio of the Value added (current Local Currency Unit) in Uganda in 1996 to that in 1998?
Your answer should be compact. 0.87. What is the ratio of the Value added (current Local Currency Unit) of Venezuela in 1996 to that in 1998?
Offer a very short reply. 0.49. What is the ratio of the Value added (current Local Currency Unit) in Myanmar in 1996 to that in 1999?
Your response must be concise. 0.36. What is the ratio of the Value added (current Local Currency Unit) of Uganda in 1996 to that in 1999?
Provide a succinct answer. 0.88. What is the ratio of the Value added (current Local Currency Unit) of Venezuela in 1996 to that in 1999?
Provide a succinct answer. 0.47. What is the ratio of the Value added (current Local Currency Unit) of Myanmar in 1996 to that in 2000?
Provide a short and direct response. 0.33. What is the ratio of the Value added (current Local Currency Unit) of Uganda in 1996 to that in 2000?
Offer a terse response. 0.98. What is the ratio of the Value added (current Local Currency Unit) of Venezuela in 1996 to that in 2000?
Provide a succinct answer. 0.38. What is the ratio of the Value added (current Local Currency Unit) in Myanmar in 1996 to that in 2001?
Offer a terse response. 0.23. What is the ratio of the Value added (current Local Currency Unit) of Uganda in 1996 to that in 2001?
Keep it short and to the point. 0.88. What is the ratio of the Value added (current Local Currency Unit) of Venezuela in 1996 to that in 2001?
Offer a terse response. 0.32. What is the ratio of the Value added (current Local Currency Unit) of Myanmar in 1997 to that in 1998?
Your response must be concise. 0.69. What is the ratio of the Value added (current Local Currency Unit) in Uganda in 1997 to that in 1998?
Keep it short and to the point. 0.87. What is the ratio of the Value added (current Local Currency Unit) in Venezuela in 1997 to that in 1998?
Your answer should be compact. 0.76. What is the ratio of the Value added (current Local Currency Unit) of Myanmar in 1997 to that in 1999?
Make the answer very short. 0.5. What is the ratio of the Value added (current Local Currency Unit) of Uganda in 1997 to that in 1999?
Keep it short and to the point. 0.89. What is the ratio of the Value added (current Local Currency Unit) in Venezuela in 1997 to that in 1999?
Keep it short and to the point. 0.73. What is the ratio of the Value added (current Local Currency Unit) of Myanmar in 1997 to that in 2000?
Offer a terse response. 0.45. What is the ratio of the Value added (current Local Currency Unit) in Uganda in 1997 to that in 2000?
Make the answer very short. 0.98. What is the ratio of the Value added (current Local Currency Unit) in Venezuela in 1997 to that in 2000?
Offer a very short reply. 0.6. What is the ratio of the Value added (current Local Currency Unit) of Myanmar in 1997 to that in 2001?
Your answer should be very brief. 0.33. What is the ratio of the Value added (current Local Currency Unit) of Uganda in 1997 to that in 2001?
Your response must be concise. 0.88. What is the ratio of the Value added (current Local Currency Unit) in Venezuela in 1997 to that in 2001?
Give a very brief answer. 0.5. What is the ratio of the Value added (current Local Currency Unit) in Myanmar in 1998 to that in 1999?
Your response must be concise. 0.72. What is the ratio of the Value added (current Local Currency Unit) of Uganda in 1998 to that in 1999?
Make the answer very short. 1.02. What is the ratio of the Value added (current Local Currency Unit) of Venezuela in 1998 to that in 1999?
Offer a terse response. 0.96. What is the ratio of the Value added (current Local Currency Unit) in Myanmar in 1998 to that in 2000?
Ensure brevity in your answer.  0.65. What is the ratio of the Value added (current Local Currency Unit) in Uganda in 1998 to that in 2000?
Offer a terse response. 1.12. What is the ratio of the Value added (current Local Currency Unit) of Venezuela in 1998 to that in 2000?
Your response must be concise. 0.79. What is the ratio of the Value added (current Local Currency Unit) in Myanmar in 1998 to that in 2001?
Provide a short and direct response. 0.47. What is the ratio of the Value added (current Local Currency Unit) of Uganda in 1998 to that in 2001?
Provide a succinct answer. 1.01. What is the ratio of the Value added (current Local Currency Unit) in Venezuela in 1998 to that in 2001?
Your response must be concise. 0.66. What is the ratio of the Value added (current Local Currency Unit) in Myanmar in 1999 to that in 2000?
Provide a short and direct response. 0.9. What is the ratio of the Value added (current Local Currency Unit) of Uganda in 1999 to that in 2000?
Provide a short and direct response. 1.1. What is the ratio of the Value added (current Local Currency Unit) in Venezuela in 1999 to that in 2000?
Provide a succinct answer. 0.82. What is the ratio of the Value added (current Local Currency Unit) of Myanmar in 1999 to that in 2001?
Provide a succinct answer. 0.65. What is the ratio of the Value added (current Local Currency Unit) in Uganda in 1999 to that in 2001?
Your response must be concise. 0.99. What is the ratio of the Value added (current Local Currency Unit) in Venezuela in 1999 to that in 2001?
Ensure brevity in your answer.  0.69. What is the ratio of the Value added (current Local Currency Unit) of Myanmar in 2000 to that in 2001?
Offer a very short reply. 0.72. What is the ratio of the Value added (current Local Currency Unit) of Uganda in 2000 to that in 2001?
Offer a terse response. 0.9. What is the ratio of the Value added (current Local Currency Unit) in Venezuela in 2000 to that in 2001?
Offer a terse response. 0.83. What is the difference between the highest and the second highest Value added (current Local Currency Unit) of Myanmar?
Provide a succinct answer. 5.64e+11. What is the difference between the highest and the second highest Value added (current Local Currency Unit) in Uganda?
Ensure brevity in your answer.  2.81e+1. What is the difference between the highest and the second highest Value added (current Local Currency Unit) in Venezuela?
Ensure brevity in your answer.  6.31e+08. What is the difference between the highest and the lowest Value added (current Local Currency Unit) of Myanmar?
Make the answer very short. 1.73e+12. What is the difference between the highest and the lowest Value added (current Local Currency Unit) of Uganda?
Your answer should be very brief. 8.64e+11. What is the difference between the highest and the lowest Value added (current Local Currency Unit) of Venezuela?
Make the answer very short. 3.34e+09. 